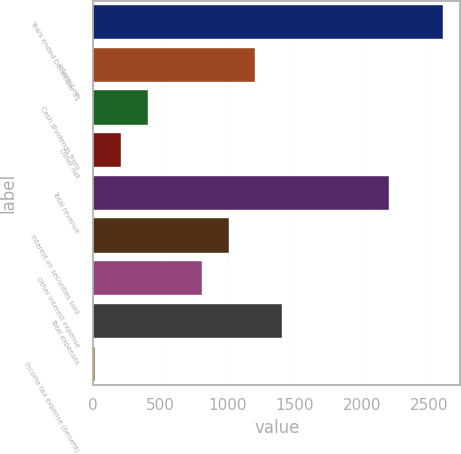Convert chart to OTSL. <chart><loc_0><loc_0><loc_500><loc_500><bar_chart><fcel>Years ended December 31<fcel>Interest on<fcel>Cash dividends from<fcel>Other net<fcel>Total revenue<fcel>Interest on securities sold<fcel>Other interest expense<fcel>Total expenses<fcel>Income tax expense (benefit)<nl><fcel>2601.9<fcel>1206.8<fcel>409.6<fcel>210.3<fcel>2203.3<fcel>1007.5<fcel>808.2<fcel>1406.1<fcel>11<nl></chart> 